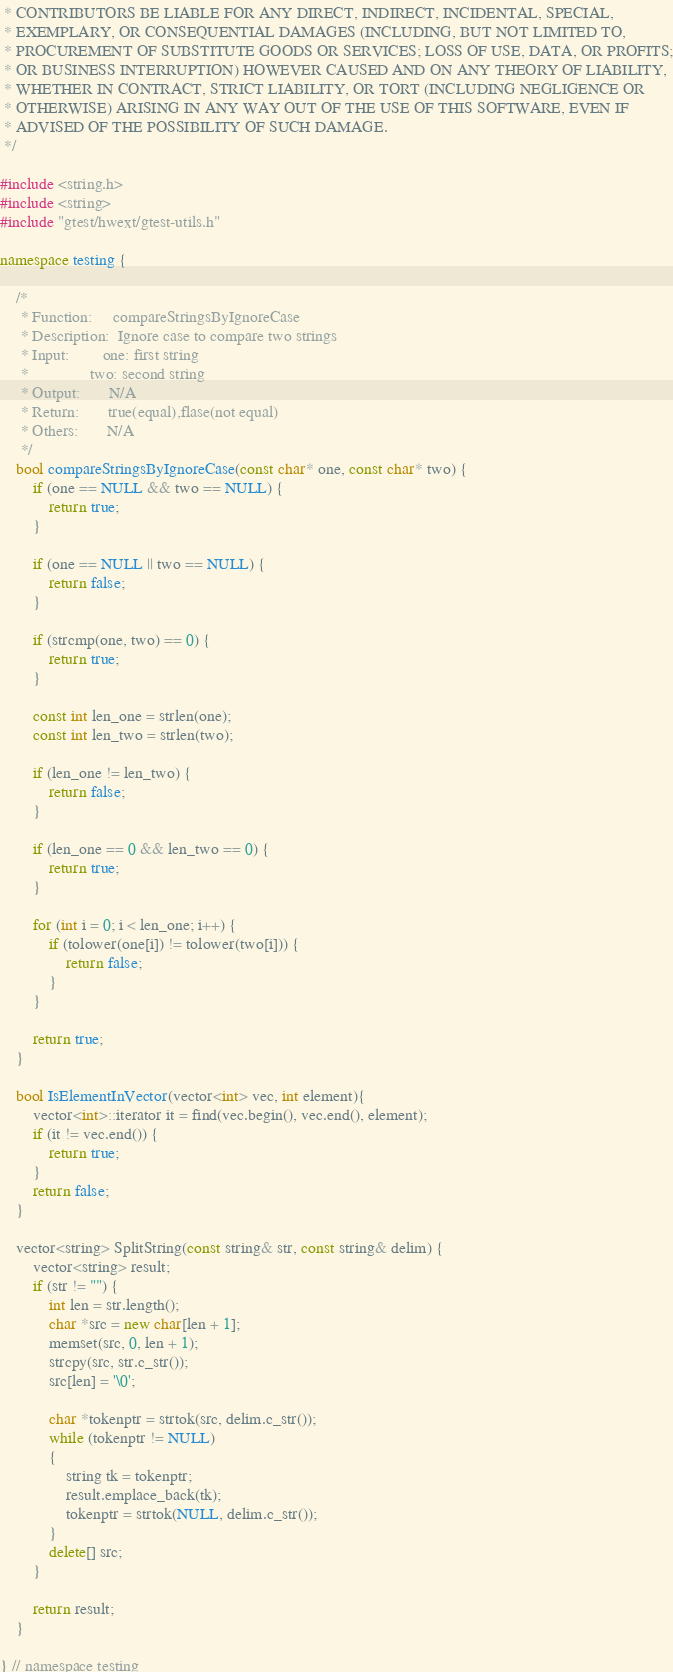<code> <loc_0><loc_0><loc_500><loc_500><_C++_> * CONTRIBUTORS BE LIABLE FOR ANY DIRECT, INDIRECT, INCIDENTAL, SPECIAL,
 * EXEMPLARY, OR CONSEQUENTIAL DAMAGES (INCLUDING, BUT NOT LIMITED TO,
 * PROCUREMENT OF SUBSTITUTE GOODS OR SERVICES; LOSS OF USE, DATA, OR PROFITS;
 * OR BUSINESS INTERRUPTION) HOWEVER CAUSED AND ON ANY THEORY OF LIABILITY,
 * WHETHER IN CONTRACT, STRICT LIABILITY, OR TORT (INCLUDING NEGLIGENCE OR
 * OTHERWISE) ARISING IN ANY WAY OUT OF THE USE OF THIS SOFTWARE, EVEN IF
 * ADVISED OF THE POSSIBILITY OF SUCH DAMAGE.
 */

#include <string.h>
#include <string>
#include "gtest/hwext/gtest-utils.h"

namespace testing {

    /*
     * Function:     compareStringsByIgnoreCase
     * Description:  Ignore case to compare two strings
     * Input:        one: first string
     *               two: second string
     * Output:       N/A
     * Return:       true(equal),flase(not equal)
     * Others:       N/A
     */
    bool compareStringsByIgnoreCase(const char* one, const char* two) {
        if (one == NULL && two == NULL) {
            return true;
        }

        if (one == NULL || two == NULL) {
            return false;
        }

        if (strcmp(one, two) == 0) {
            return true;
        }

        const int len_one = strlen(one);
        const int len_two = strlen(two);

        if (len_one != len_two) {
            return false;
        }

        if (len_one == 0 && len_two == 0) {
            return true;
        }

        for (int i = 0; i < len_one; i++) {
            if (tolower(one[i]) != tolower(two[i])) {
                return false;
            }
        }

        return true;
    }

    bool IsElementInVector(vector<int> vec, int element){
        vector<int>::iterator it = find(vec.begin(), vec.end(), element);
        if (it != vec.end()) {
            return true;
        }
        return false;
    }

    vector<string> SplitString(const string& str, const string& delim) {
        vector<string> result;
        if (str != "") {
            int len = str.length();
            char *src = new char[len + 1];
            memset(src, 0, len + 1);
            strcpy(src, str.c_str());
            src[len] = '\0';

            char *tokenptr = strtok(src, delim.c_str());
            while (tokenptr != NULL)
            {
                string tk = tokenptr;
                result.emplace_back(tk);
                tokenptr = strtok(NULL, delim.c_str());
            }
            delete[] src;
        }

        return result;
    }

} // namespace testing
</code> 